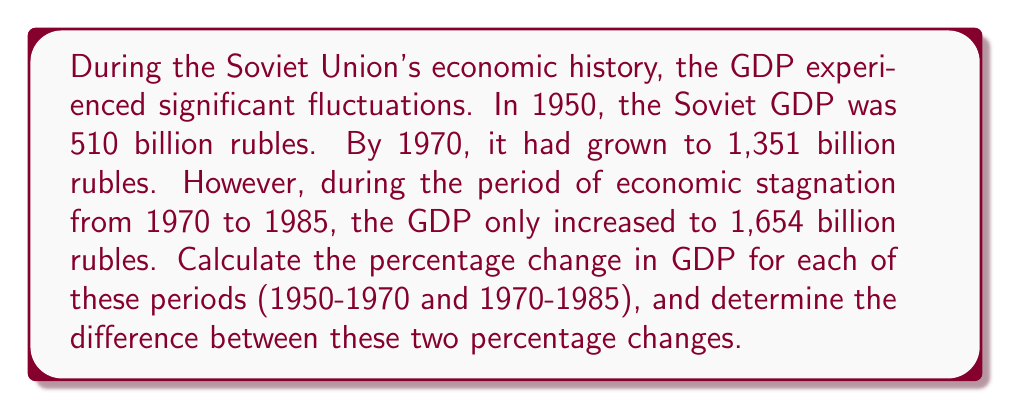Can you solve this math problem? To calculate the percentage change in GDP, we'll use the formula:

$$ \text{Percentage Change} = \frac{\text{New Value} - \text{Original Value}}{\text{Original Value}} \times 100\% $$

1. For the period 1950-1970:
   Original Value = 510 billion rubles
   New Value = 1,351 billion rubles

   $$ \text{Percentage Change} = \frac{1351 - 510}{510} \times 100\% = \frac{841}{510} \times 100\% = 164.90\% $$

2. For the period 1970-1985:
   Original Value = 1,351 billion rubles
   New Value = 1,654 billion rubles

   $$ \text{Percentage Change} = \frac{1654 - 1351}{1351} \times 100\% = \frac{303}{1351} \times 100\% = 22.43\% $$

3. To find the difference between these two percentage changes:

   $$ \text{Difference} = 164.90\% - 22.43\% = 142.47\% $$

This significant difference in percentage changes illustrates the contrast between the rapid economic growth in the earlier period and the economic stagnation in the later period of Soviet history.
Answer: 142.47% 